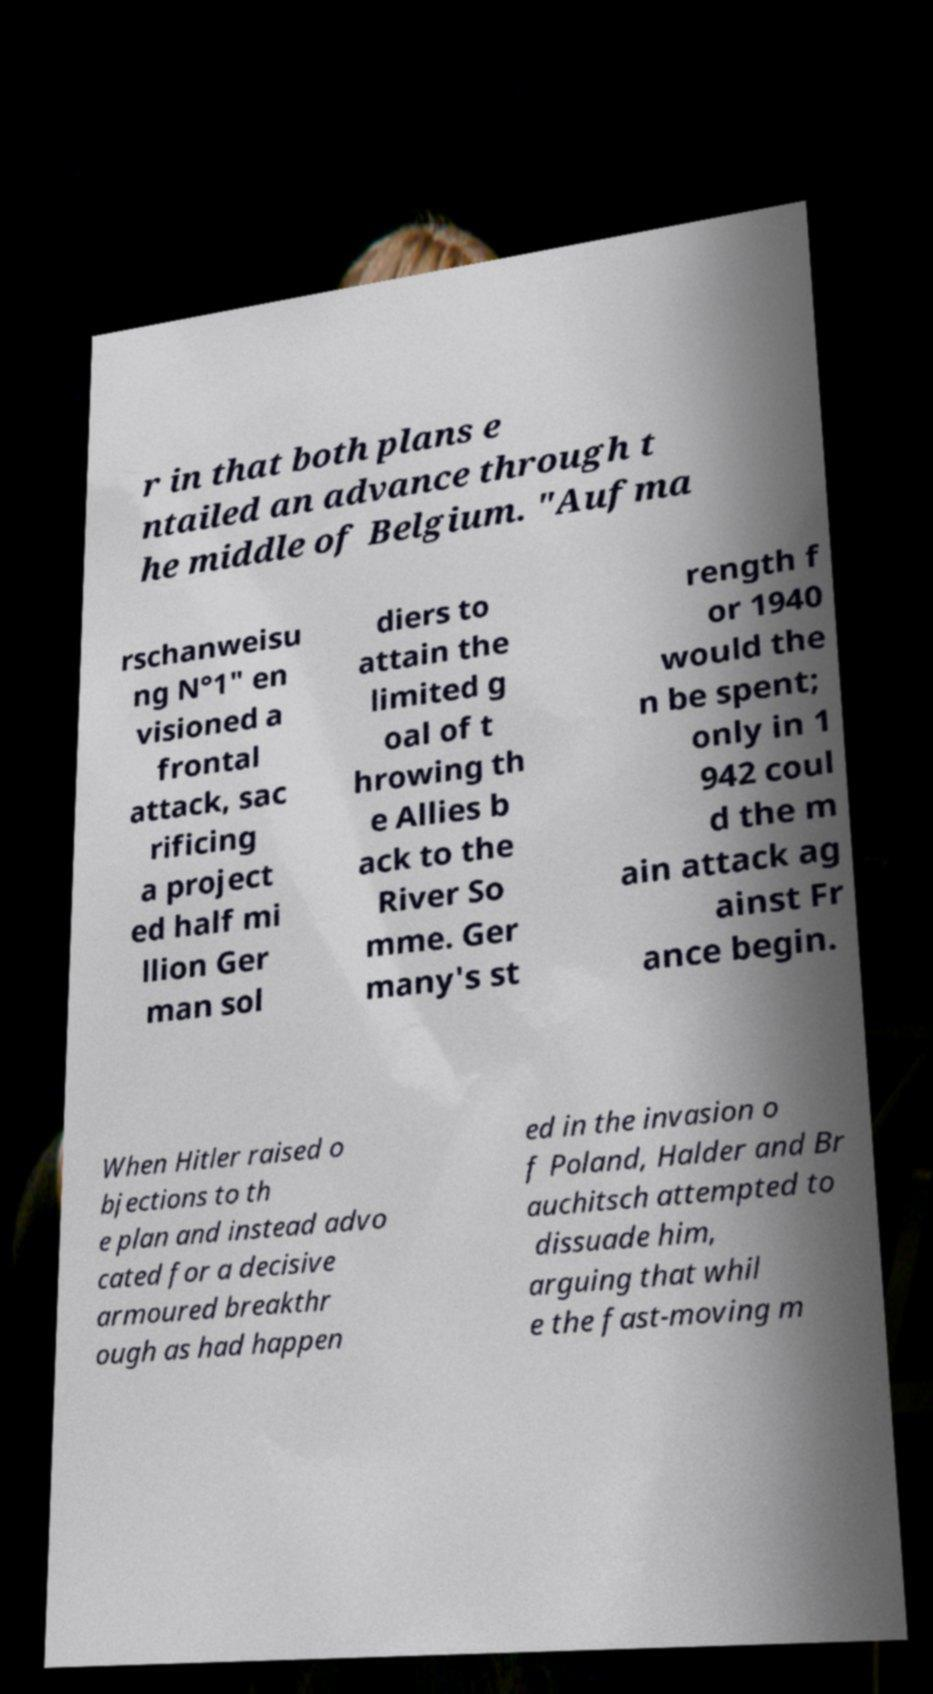Can you accurately transcribe the text from the provided image for me? r in that both plans e ntailed an advance through t he middle of Belgium. "Aufma rschanweisu ng N°1" en visioned a frontal attack, sac rificing a project ed half mi llion Ger man sol diers to attain the limited g oal of t hrowing th e Allies b ack to the River So mme. Ger many's st rength f or 1940 would the n be spent; only in 1 942 coul d the m ain attack ag ainst Fr ance begin. When Hitler raised o bjections to th e plan and instead advo cated for a decisive armoured breakthr ough as had happen ed in the invasion o f Poland, Halder and Br auchitsch attempted to dissuade him, arguing that whil e the fast-moving m 